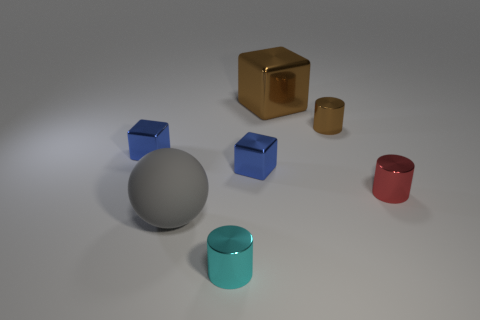Add 3 cyan cylinders. How many objects exist? 10 Subtract all cylinders. How many objects are left? 4 Add 7 tiny blue metal things. How many tiny blue metal things are left? 9 Add 4 rubber spheres. How many rubber spheres exist? 5 Subtract 0 purple blocks. How many objects are left? 7 Subtract all tiny brown cylinders. Subtract all large blocks. How many objects are left? 5 